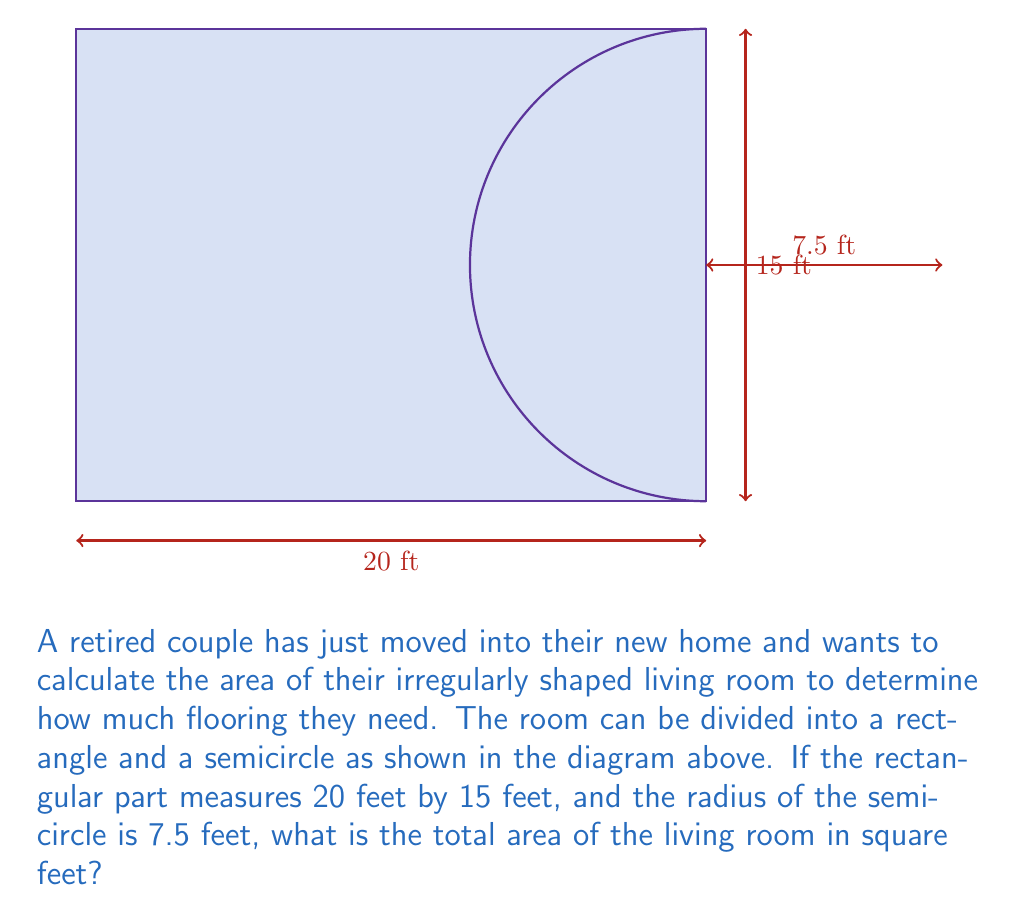Give your solution to this math problem. To solve this problem, we need to calculate the areas of the rectangular part and the semicircular part separately, then add them together.

1. Area of the rectangle:
   $A_{rectangle} = length \times width$
   $A_{rectangle} = 20 \text{ ft} \times 15 \text{ ft} = 300 \text{ sq ft}$

2. Area of the semicircle:
   The area of a full circle is $\pi r^2$, so the area of a semicircle is half of that.
   $A_{semicircle} = \frac{1}{2} \pi r^2$
   $A_{semicircle} = \frac{1}{2} \pi (7.5 \text{ ft})^2$
   $A_{semicircle} = \frac{1}{2} \pi (56.25 \text{ sq ft})$
   $A_{semicircle} \approx 88.36 \text{ sq ft}$

3. Total area:
   $A_{total} = A_{rectangle} + A_{semicircle}$
   $A_{total} = 300 \text{ sq ft} + 88.36 \text{ sq ft}$
   $A_{total} \approx 388.36 \text{ sq ft}$

Therefore, the total area of the living room is approximately 388.36 square feet.
Answer: $388.36 \text{ sq ft}$ 